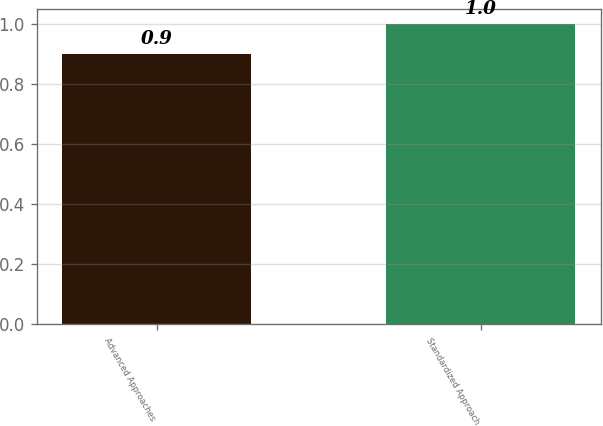Convert chart to OTSL. <chart><loc_0><loc_0><loc_500><loc_500><bar_chart><fcel>Advanced Approaches<fcel>Standardized Approach<nl><fcel>0.9<fcel>1<nl></chart> 